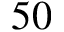Convert formula to latex. <formula><loc_0><loc_0><loc_500><loc_500>5 0</formula> 